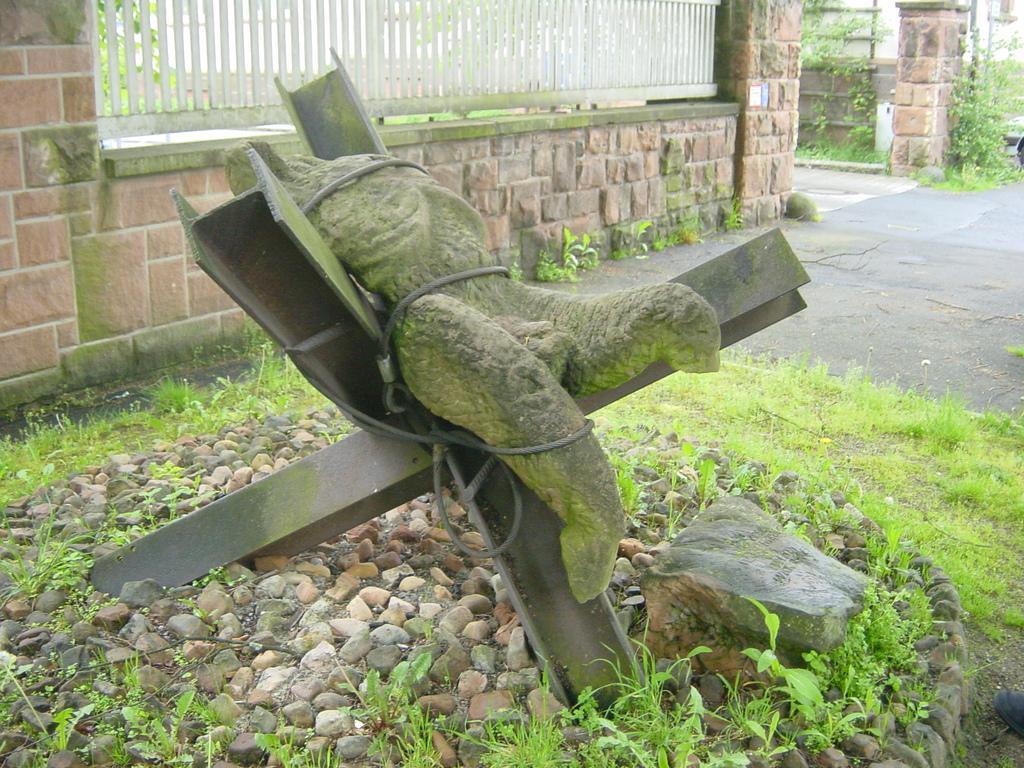Can you describe this image briefly? This picture is taken from outside of the city. In this image, in the middle, we can see a pole, on the pole, we can see a sculpture which is tied with rope. On the right side of the image, we can see a stone. In the background, we can see grill, plants, pillars. At the bottom, we can see a road and a grass with some stones. 